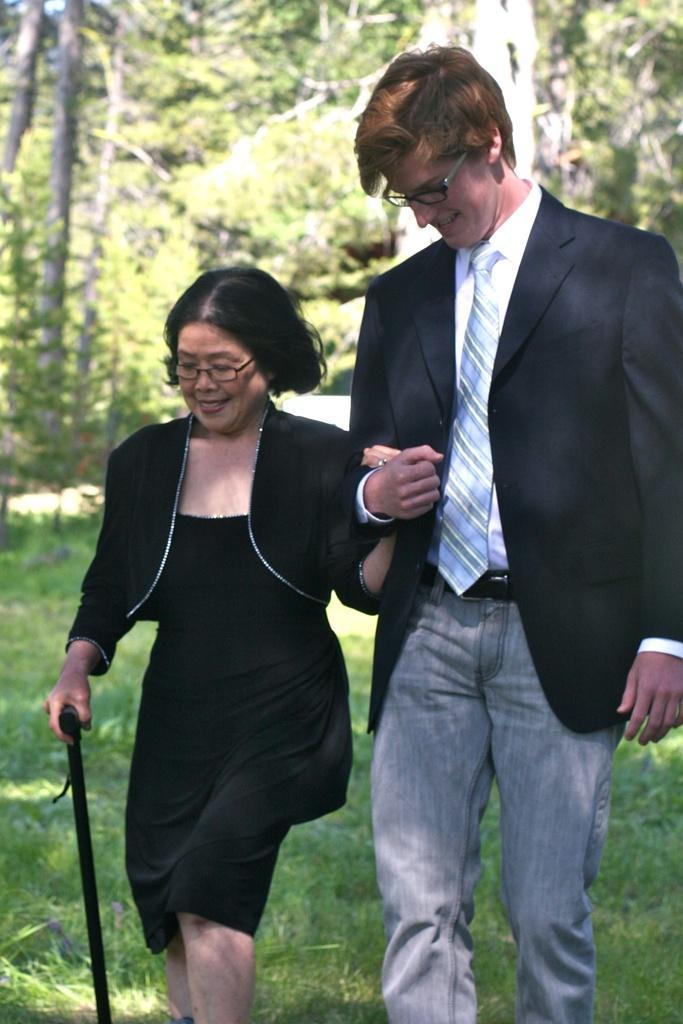Please provide a concise description of this image. In this picture I can see there is a woman and a man walking here and the woman is wearing a black dress and the man is wearing a black blazer and there's grass on the floor and there are trees in the backdrop. 